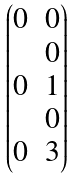<formula> <loc_0><loc_0><loc_500><loc_500>\begin{pmatrix} 0 & 0 \\ & 0 \\ 0 & 1 \\ & 0 \\ 0 & 3 \end{pmatrix}</formula> 